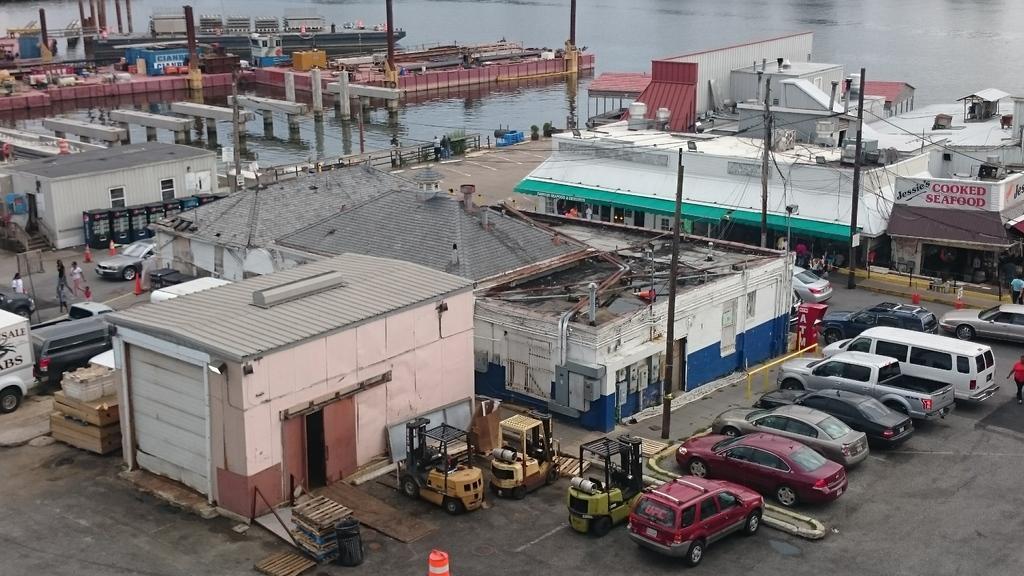Describe this image in one or two sentences. On the right side there are many vehicles parked. Also there is a road. On that there are many vehicles. Near to that there many buildings with windows and doors. Also something is written on the building. Also there are traffic cones on the road. In the back there is water. Also there are bridges and many other items on the water. 